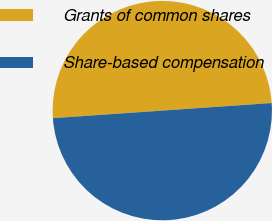Convert chart to OTSL. <chart><loc_0><loc_0><loc_500><loc_500><pie_chart><fcel>Grants of common shares<fcel>Share-based compensation<nl><fcel>50.0%<fcel>50.0%<nl></chart> 